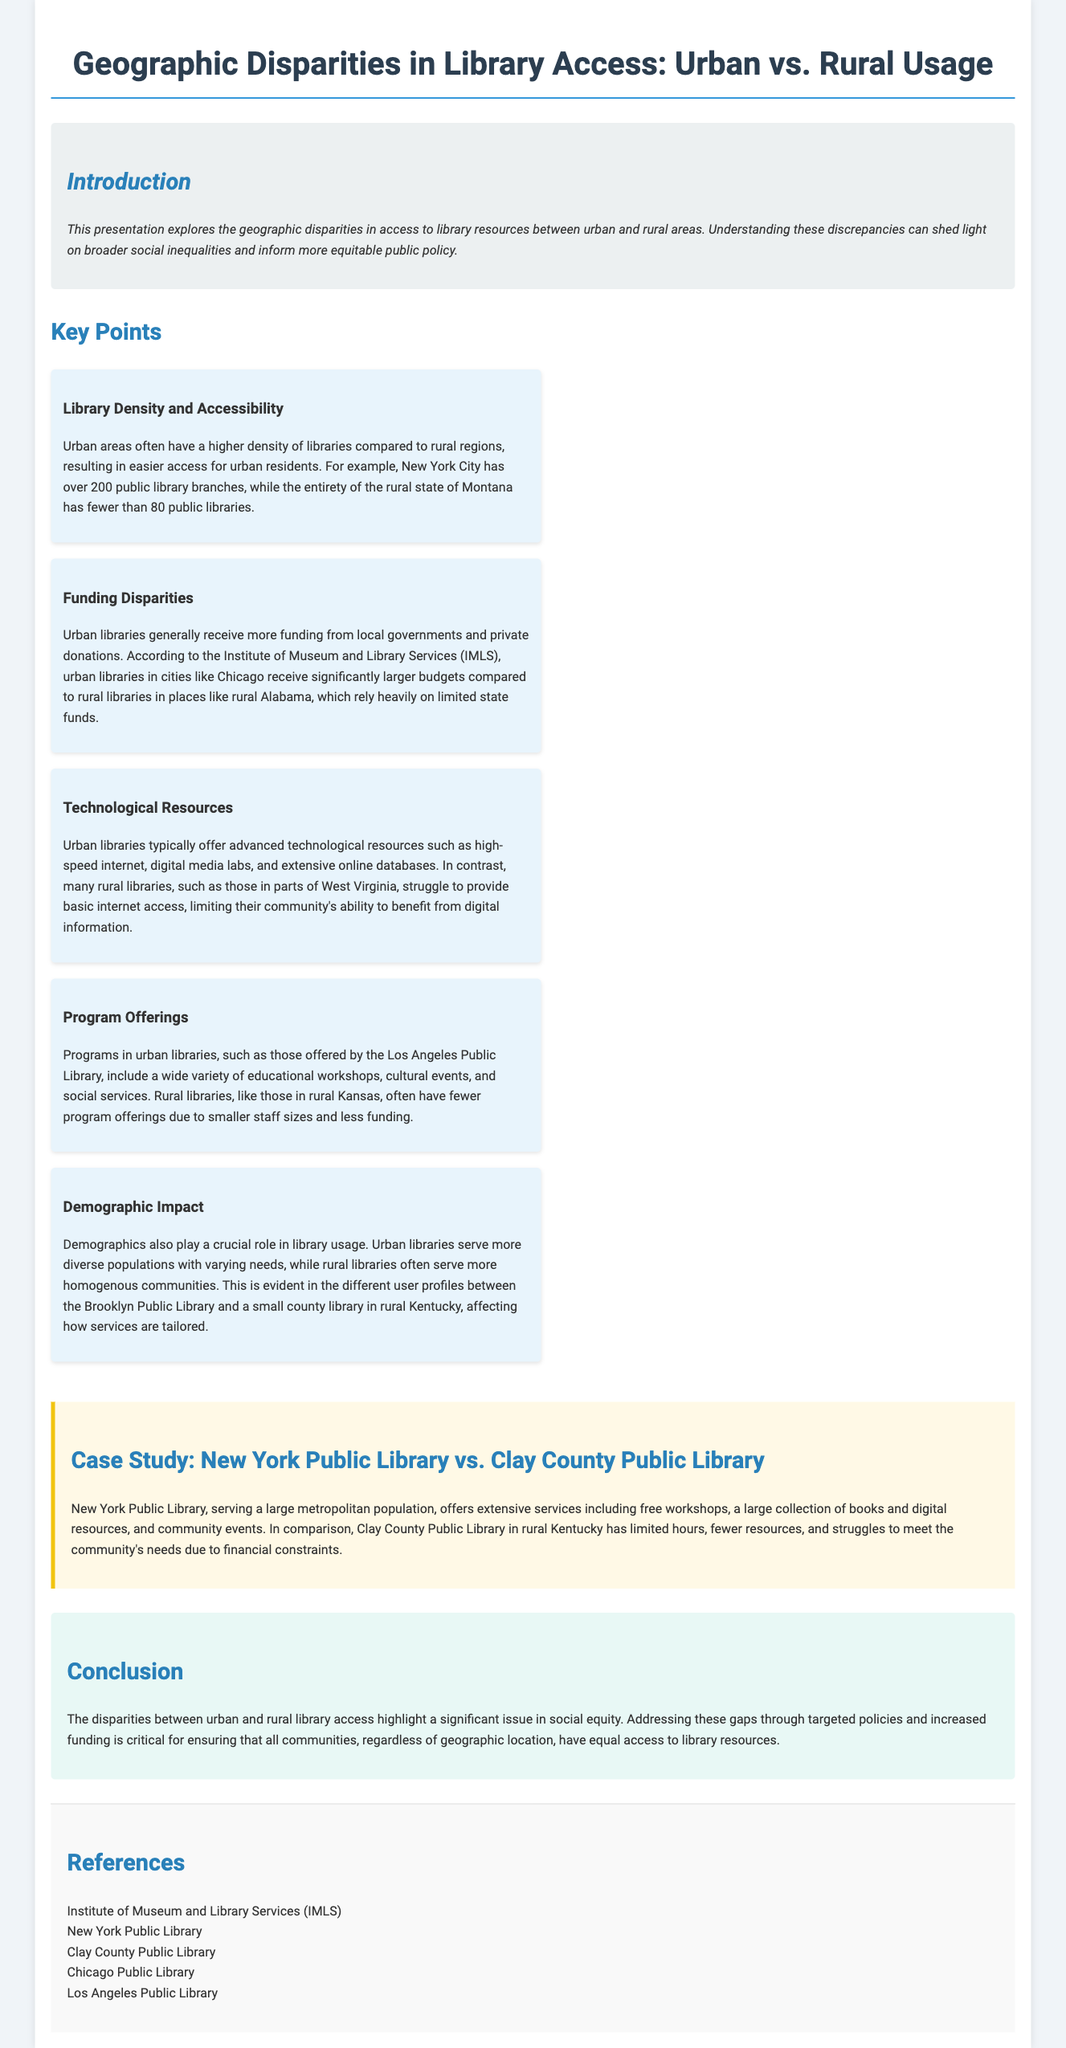What is the main topic of the presentation? The main topic of the presentation explores geographic disparities in access to library resources between urban and rural areas.
Answer: Geographic disparities in library access How many public library branches does New York City have? The document states that New York City has over 200 public library branches.
Answer: Over 200 Which state has fewer than 80 public libraries? The document mentions that the rural state of Montana has fewer than 80 public libraries.
Answer: Montana What does IMLS stand for? The acronym IMLS stands for the Institute of Museum and Library Services.
Answer: Institute of Museum and Library Services How do urban libraries benefit from funding? Urban libraries generally receive more funding from local governments and private donations.
Answer: More funding from local governments and private donations In which location does the case study compare library services? The case study compares services between New York Public Library and Clay County Public Library.
Answer: New York Public Library vs. Clay County Public Library What is a key difference in technological resources between urban and rural libraries? Urban libraries typically offer advanced technological resources such as high-speed internet, while rural libraries struggle to provide basic internet access.
Answer: Advanced technological resources vs. basic internet access What vital role do demographics play in library usage? Demographics impact library usage, as urban libraries serve diverse populations while rural libraries serve more homogenous communities.
Answer: Impact of diverse vs. homogenous communities What is suggested as a solution to the disparities in library access? The document suggests that addressing these gaps through targeted policies and increased funding is critical.
Answer: Targeted policies and increased funding 